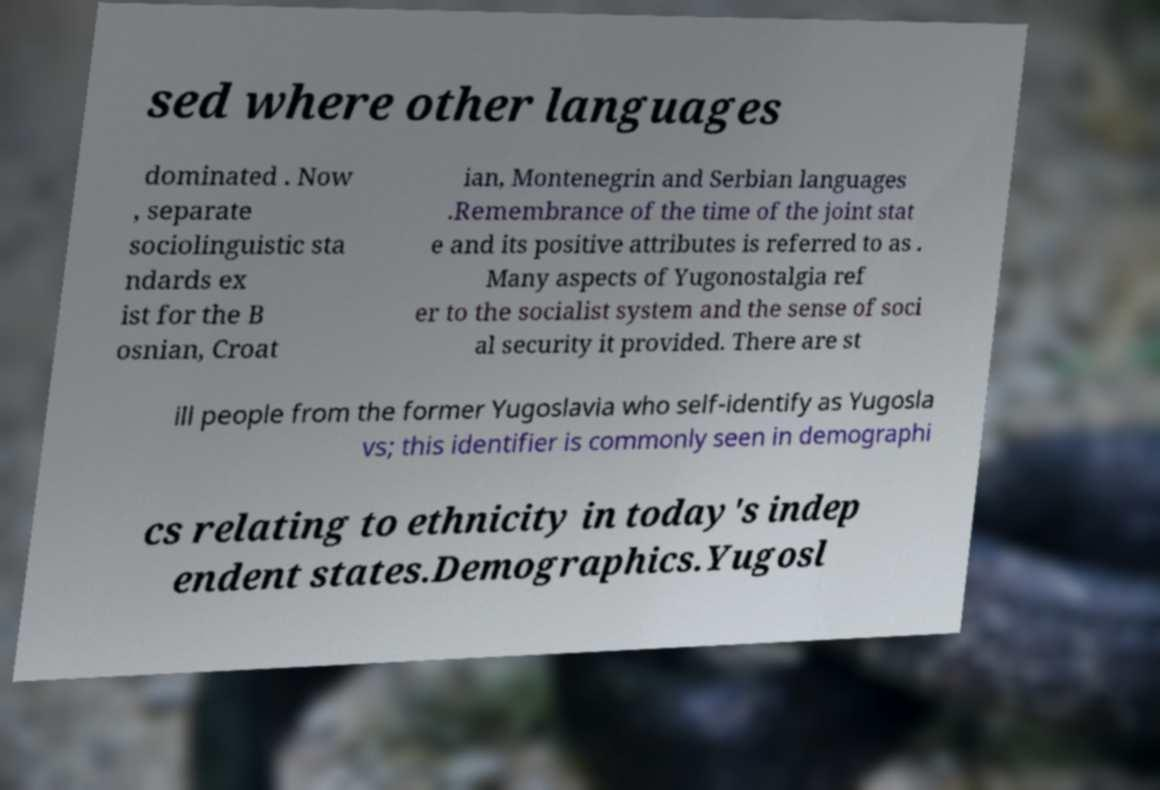Could you extract and type out the text from this image? sed where other languages dominated . Now , separate sociolinguistic sta ndards ex ist for the B osnian, Croat ian, Montenegrin and Serbian languages .Remembrance of the time of the joint stat e and its positive attributes is referred to as . Many aspects of Yugonostalgia ref er to the socialist system and the sense of soci al security it provided. There are st ill people from the former Yugoslavia who self-identify as Yugosla vs; this identifier is commonly seen in demographi cs relating to ethnicity in today's indep endent states.Demographics.Yugosl 